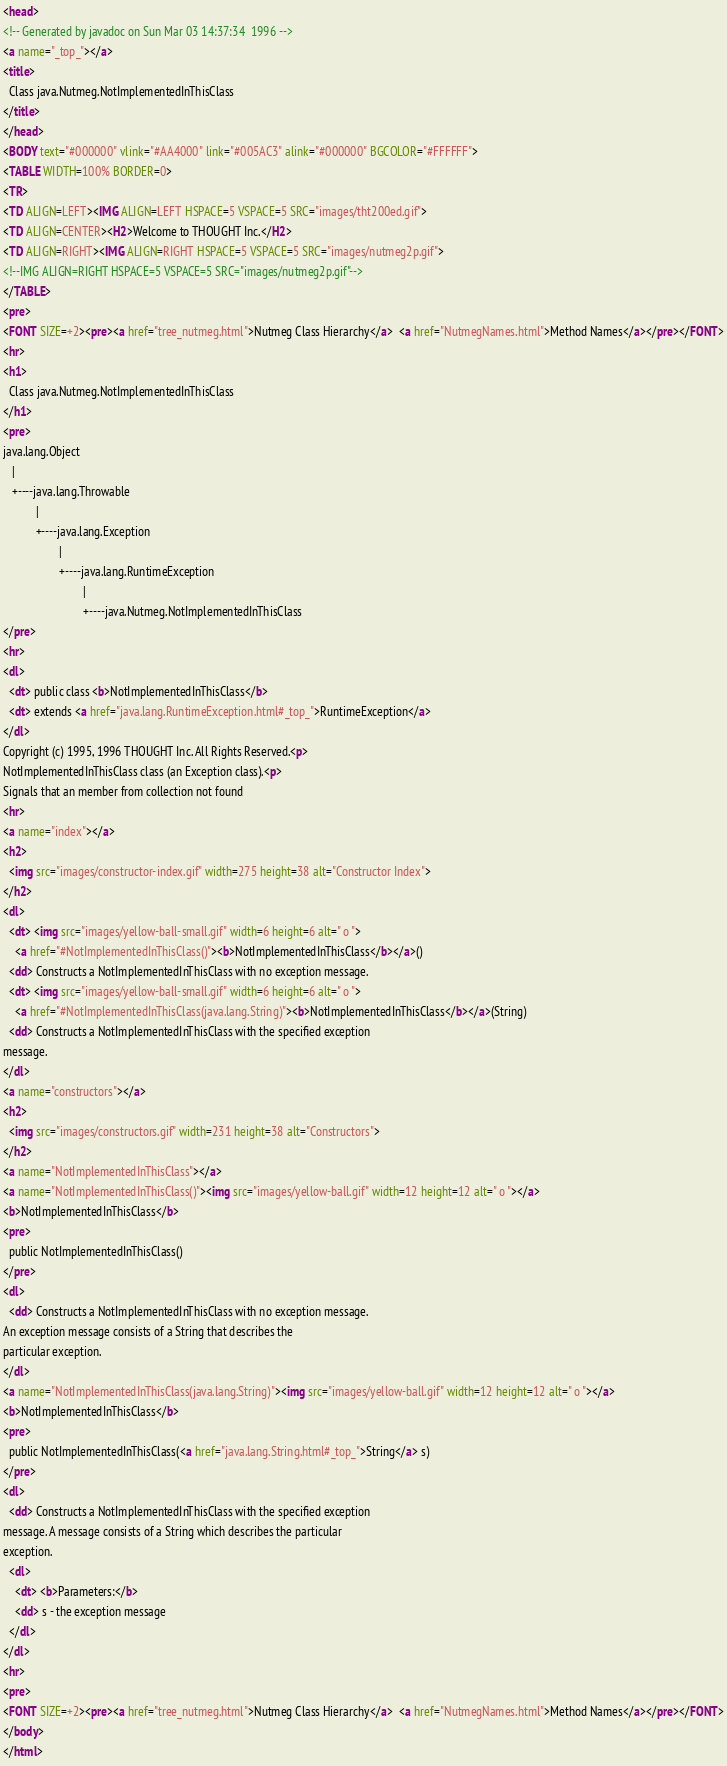<code> <loc_0><loc_0><loc_500><loc_500><_HTML_><head>
<!-- Generated by javadoc on Sun Mar 03 14:37:34  1996 -->
<a name="_top_"></a>
<title>
  Class java.Nutmeg.NotImplementedInThisClass
</title>
</head>
<BODY text="#000000" vlink="#AA4000" link="#005AC3" alink="#000000" BGCOLOR="#FFFFFF">
<TABLE WIDTH=100% BORDER=0>
<TR>
<TD ALIGN=LEFT><IMG ALIGN=LEFT HSPACE=5 VSPACE=5 SRC="images/tht200ed.gif">
<TD ALIGN=CENTER><H2>Welcome to THOUGHT Inc.</H2>
<TD ALIGN=RIGHT><IMG ALIGN=RIGHT HSPACE=5 VSPACE=5 SRC="images/nutmeg2p.gif">
<!--IMG ALIGN=RIGHT HSPACE=5 VSPACE=5 SRC="images/nutmeg2p.gif"-->
</TABLE>
<pre>
<FONT SIZE=+2><pre><a href="tree_nutmeg.html">Nutmeg Class Hierarchy</a>  <a href="NutmegNames.html">Method Names</a></pre></FONT>
<hr>
<h1>
  Class java.Nutmeg.NotImplementedInThisClass
</h1>
<pre>
java.lang.Object
   |
   +----java.lang.Throwable
           |
           +----java.lang.Exception
                   |
                   +----java.lang.RuntimeException
                           |
                           +----java.Nutmeg.NotImplementedInThisClass
</pre>
<hr>
<dl>
  <dt> public class <b>NotImplementedInThisClass</b>
  <dt> extends <a href="java.lang.RuntimeException.html#_top_">RuntimeException</a>
</dl>
Copyright (c) 1995, 1996 THOUGHT Inc. All Rights Reserved.<p>
NotImplementedInThisClass class (an Exception class).<p>
Signals that an member from collection not found
<hr>
<a name="index"></a>
<h2>
  <img src="images/constructor-index.gif" width=275 height=38 alt="Constructor Index">
</h2>
<dl>
  <dt> <img src="images/yellow-ball-small.gif" width=6 height=6 alt=" o ">
	<a href="#NotImplementedInThisClass()"><b>NotImplementedInThisClass</b></a>()
  <dd> Constructs a NotImplementedInThisClass with no exception message.
  <dt> <img src="images/yellow-ball-small.gif" width=6 height=6 alt=" o ">
	<a href="#NotImplementedInThisClass(java.lang.String)"><b>NotImplementedInThisClass</b></a>(String)
  <dd> Constructs a NotImplementedInThisClass with the specified exception 
message.
</dl>
<a name="constructors"></a>
<h2>
  <img src="images/constructors.gif" width=231 height=38 alt="Constructors">
</h2>
<a name="NotImplementedInThisClass"></a>
<a name="NotImplementedInThisClass()"><img src="images/yellow-ball.gif" width=12 height=12 alt=" o "></a>
<b>NotImplementedInThisClass</b>
<pre>
  public NotImplementedInThisClass()
</pre>
<dl>
  <dd> Constructs a NotImplementedInThisClass with no exception message.
An exception message consists of a String that describes the 
particular exception.
</dl>
<a name="NotImplementedInThisClass(java.lang.String)"><img src="images/yellow-ball.gif" width=12 height=12 alt=" o "></a>
<b>NotImplementedInThisClass</b>
<pre>
  public NotImplementedInThisClass(<a href="java.lang.String.html#_top_">String</a> s)
</pre>
<dl>
  <dd> Constructs a NotImplementedInThisClass with the specified exception 
message. A message consists of a String which describes the particular 
exception.
  <dl>
    <dt> <b>Parameters:</b>
    <dd> s - the exception message
  </dl>
</dl>
<hr>
<pre>
<FONT SIZE=+2><pre><a href="tree_nutmeg.html">Nutmeg Class Hierarchy</a>  <a href="NutmegNames.html">Method Names</a></pre></FONT>
</body>
</html>
</code> 